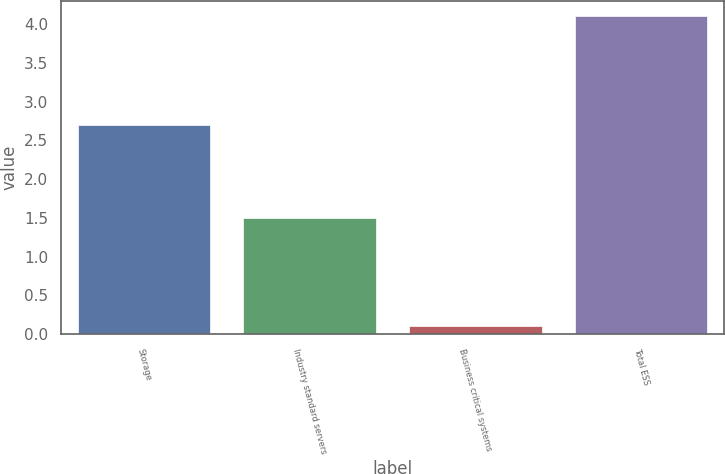Convert chart. <chart><loc_0><loc_0><loc_500><loc_500><bar_chart><fcel>Storage<fcel>Industry standard servers<fcel>Business critical systems<fcel>Total ESS<nl><fcel>2.7<fcel>1.5<fcel>0.1<fcel>4.1<nl></chart> 